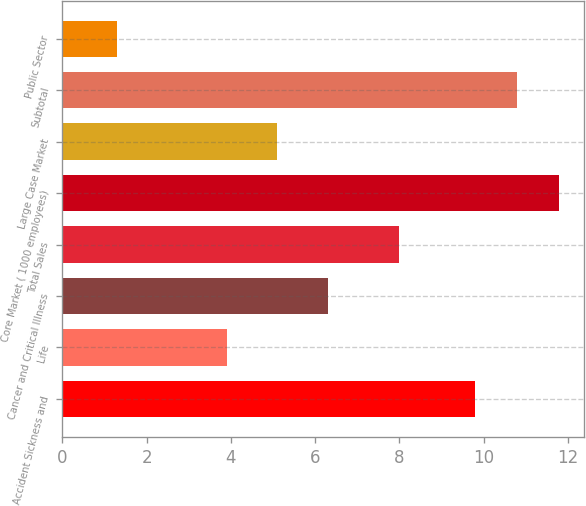Convert chart to OTSL. <chart><loc_0><loc_0><loc_500><loc_500><bar_chart><fcel>Accident Sickness and<fcel>Life<fcel>Cancer and Critical Illness<fcel>Total Sales<fcel>Core Market ( 1000 employees)<fcel>Large Case Market<fcel>Subtotal<fcel>Public Sector<nl><fcel>9.8<fcel>3.9<fcel>6.3<fcel>8<fcel>11.8<fcel>5.1<fcel>10.8<fcel>1.3<nl></chart> 